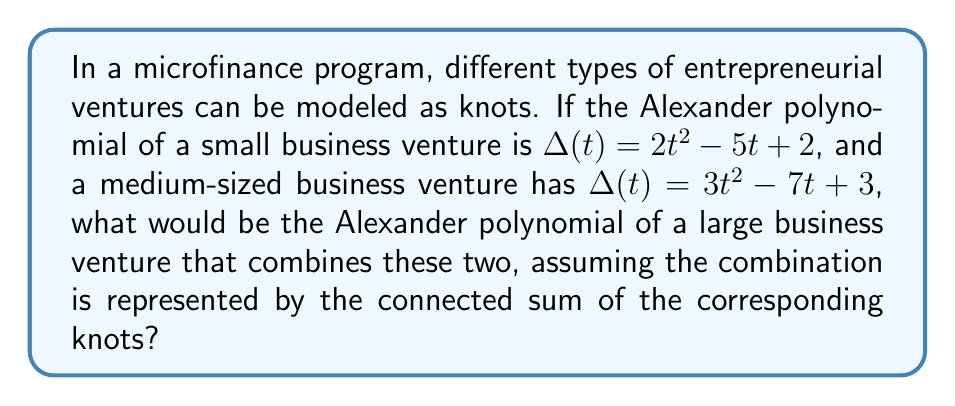Solve this math problem. To solve this problem, we need to follow these steps:

1. Recall that for a connected sum of two knots $K_1$ and $K_2$, the Alexander polynomial of the resulting knot is the product of the Alexander polynomials of the individual knots:

   $\Delta_{K_1 \# K_2}(t) = \Delta_{K_1}(t) \cdot \Delta_{K_2}(t)$

2. Let's define:
   $\Delta_{K_1}(t) = 2t^2 - 5t + 2$ (small business venture)
   $\Delta_{K_2}(t) = 3t^2 - 7t + 3$ (medium-sized business venture)

3. Multiply these polynomials:

   $\Delta_{K_1 \# K_2}(t) = (2t^2 - 5t + 2)(3t^2 - 7t + 3)$

4. Expand the product:

   $\Delta_{K_1 \# K_2}(t) = (2t^2)(3t^2) + (2t^2)(-7t) + (2t^2)(3) + 
                              (-5t)(3t^2) + (-5t)(-7t) + (-5t)(3) + 
                              (2)(3t^2) + (2)(-7t) + (2)(3)$

5. Simplify:

   $\Delta_{K_1 \# K_2}(t) = 6t^4 - 14t^3 + 6t^2 - 15t^3 + 35t^2 - 15t + 6t^2 - 14t + 6$

6. Collect like terms:

   $\Delta_{K_1 \# K_2}(t) = 6t^4 - 29t^3 + 47t^2 - 29t + 6$

This polynomial represents the Alexander polynomial of the large business venture that combines the small and medium-sized ventures.
Answer: $6t^4 - 29t^3 + 47t^2 - 29t + 6$ 